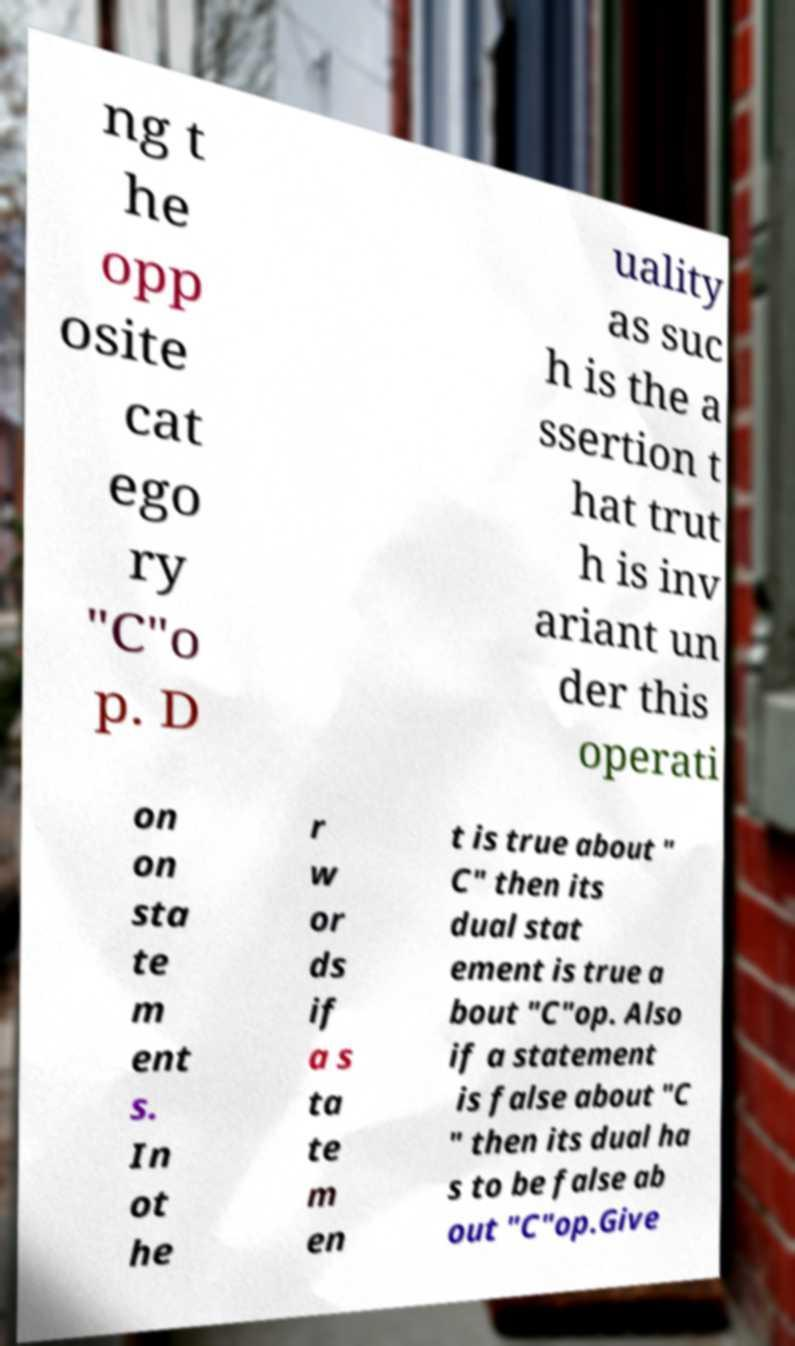For documentation purposes, I need the text within this image transcribed. Could you provide that? ng t he opp osite cat ego ry "C"o p. D uality as suc h is the a ssertion t hat trut h is inv ariant un der this operati on on sta te m ent s. In ot he r w or ds if a s ta te m en t is true about " C" then its dual stat ement is true a bout "C"op. Also if a statement is false about "C " then its dual ha s to be false ab out "C"op.Give 